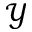<formula> <loc_0><loc_0><loc_500><loc_500>\mathcal { Y }</formula> 